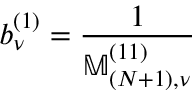<formula> <loc_0><loc_0><loc_500><loc_500>b _ { \nu } ^ { ( 1 ) } = \frac { 1 } { \mathbb { M } _ { ( N + 1 ) , \nu } ^ { ( 1 1 ) } }</formula> 